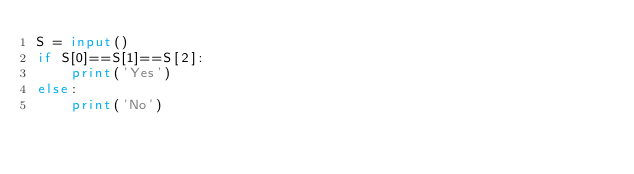Convert code to text. <code><loc_0><loc_0><loc_500><loc_500><_Python_>S = input()
if S[0]==S[1]==S[2]:
    print('Yes')
else:
    print('No')</code> 